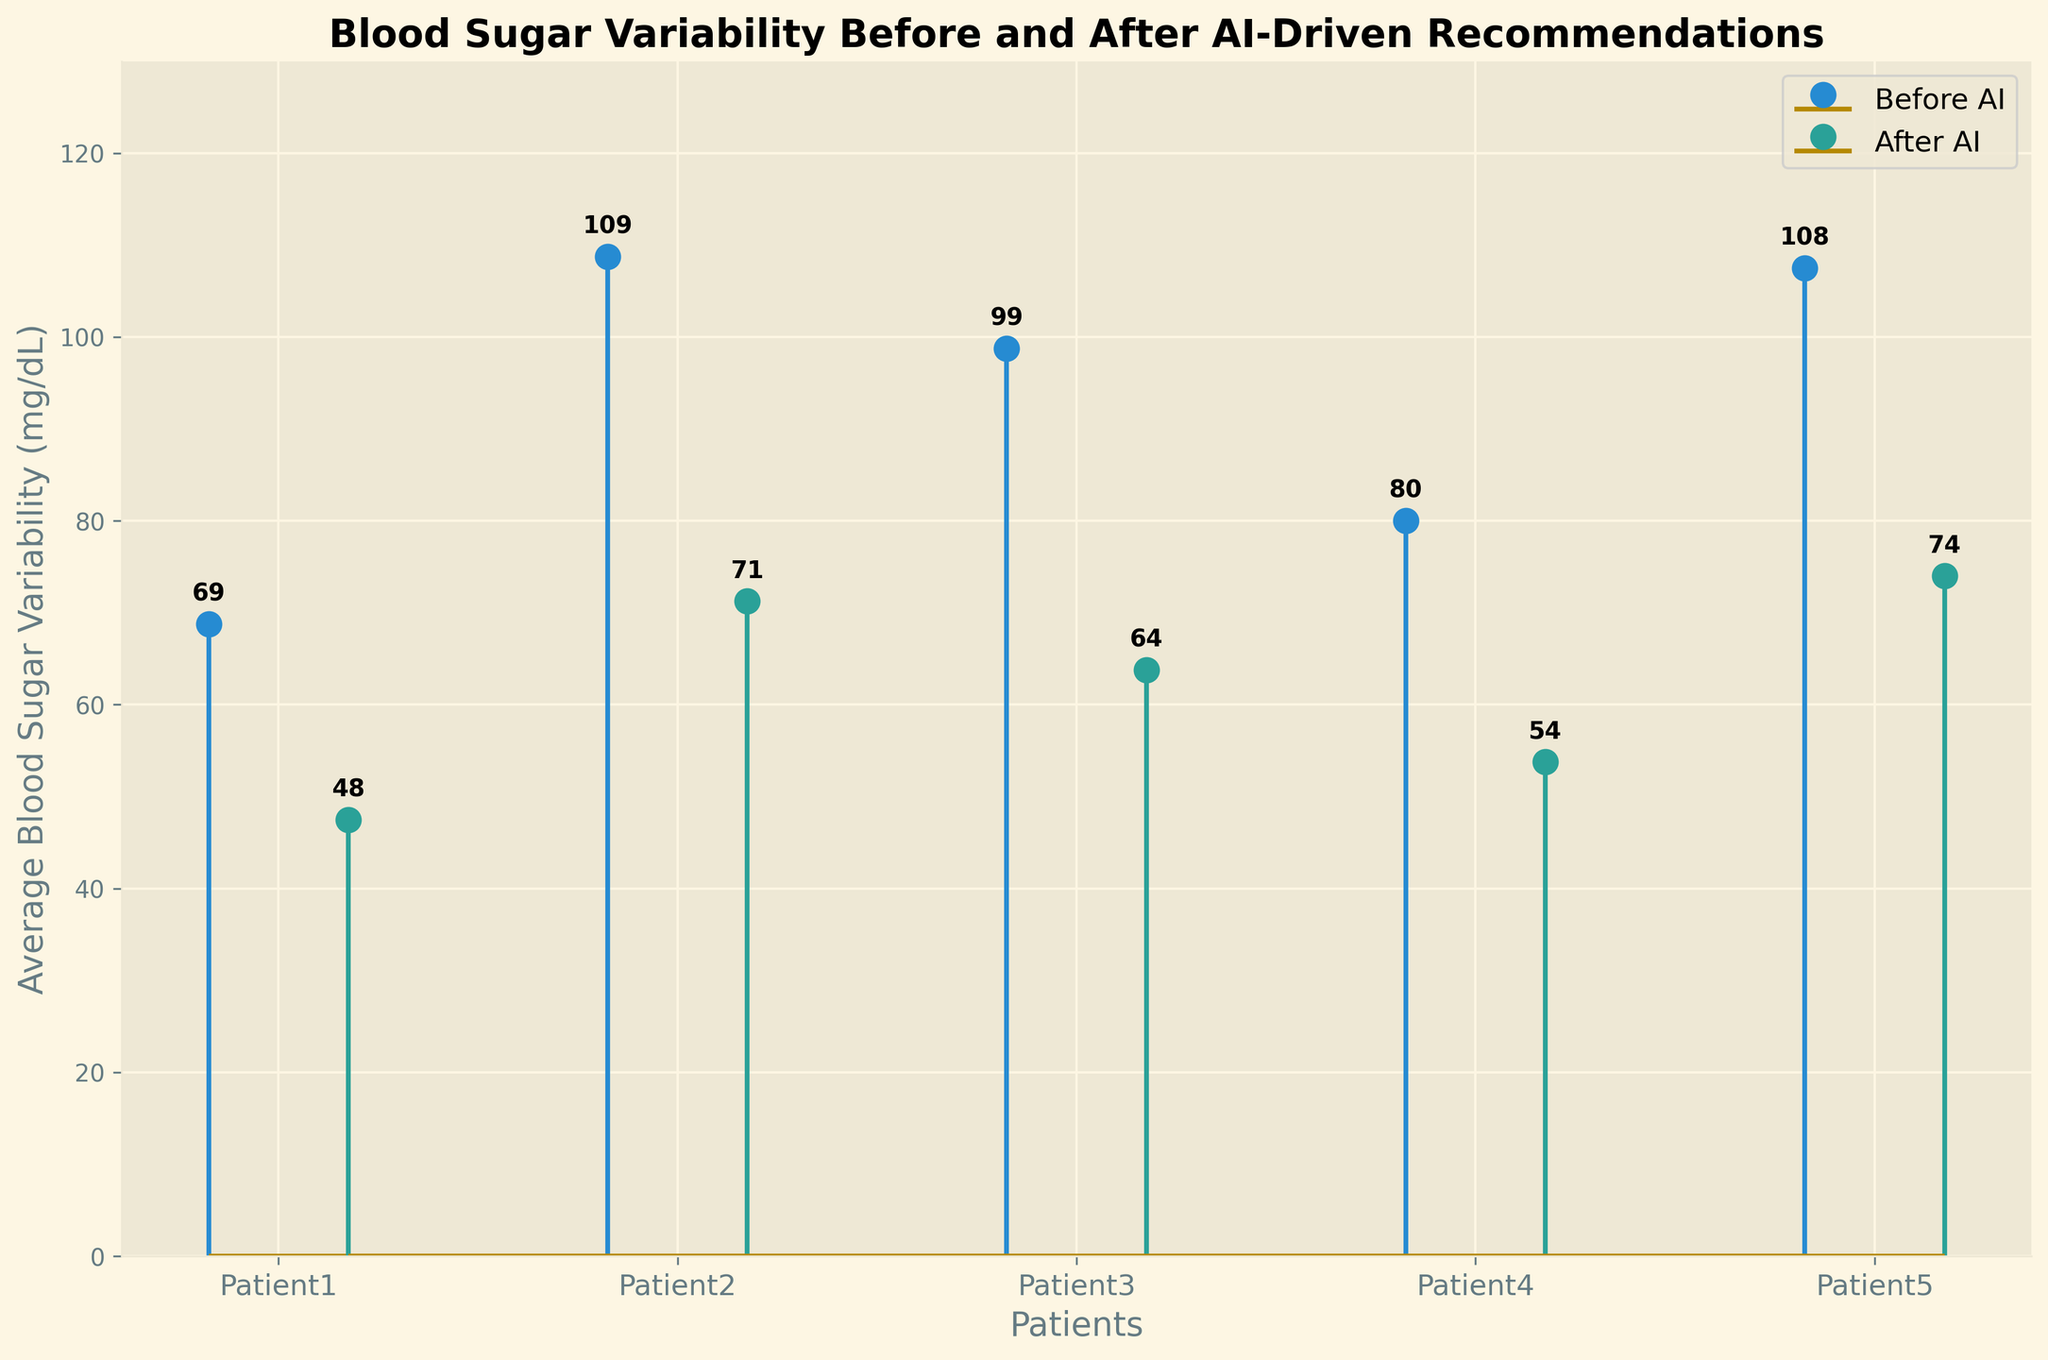what is the title of the figure? The title is typically displayed at the top of the figure. In this case, it is "Blood Sugar Variability Before and After AI-Driven Recommendations". The title provides a summary of what the figure represents.
Answer: Blood Sugar Variability Before and After AI-Driven Recommendations Which patient showed the largest decrease in blood sugar variability after implementing AI-driven recommendations? To determine the largest decrease, we subtract the "After AI" value from the "Before AI" value for each patient. The largest positive difference indicates the biggest drop. Patient 2 had the highest decrease, reducing from an average of 108.75 (before) to 71.25 (after), a difference of 37.5.
Answer: Patient 2 What is the average blood sugar variability for Patient 3 before and after AI? The "Before AI" values for Patient 3 are 90, 95, 100, and 110, averaging to (90+95+100+110)/4 = 98.75. The "After AI" values are 60, 62, 65, and 68, averaging to (60+62+65+68)/4 = 63.75. Thus, the averages are 98.75 (before) and 63.75 (after).
Answer: 98.75, 63.75 What is the overall trend in blood sugar variability across patients after AI recommendations? By examining the stem plots, we can see that for each patient, the bars representing the "After AI" data are consistently lower than the "Before AI" bars, indicating a general trend of reduced blood sugar variability.
Answer: Decrease Which patient had the least variability in blood sugar levels after AI recommendations? Of the "After AI" average values, Patient 1 had the lowest at 47.5 mg/dL.
Answer: Patient 1 How are the patients visually represented on the x-axis? The x-axis labels represent different patients. They are spaced evenly across the axis and labeled from left to right as Patient1, Patient2, etc.
Answer: By patient labels (Patient1, Patient2, etc.) What are the blood sugar variability values for Patient 4 before and after AI? From the figure, the average "Before AI" value for Patient 4 is 80 and the "After AI" value is 53.75.
Answer: 80, 53.75 Which patient had the highest blood sugar variability before AI recommendations? By comparing the average values represented in the "Before AI" stems, Patient 2 had the highest average at 108.75 mg/dL.
Answer: Patient 2 Identify the patient with the smallest difference in blood sugar variability before and after AI recommendations. To find the smallest difference, we subtract the "After AI" average value from the "Before AI" average value for each patient. Patient 5 has the smallest difference, going from 107.5 (before) to 74 (after), a difference of 33.5.
Answer: Patient 5 